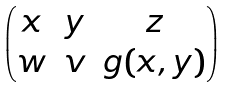<formula> <loc_0><loc_0><loc_500><loc_500>\begin{pmatrix} x & y & z \\ w & v & g ( x , y ) \end{pmatrix}</formula> 